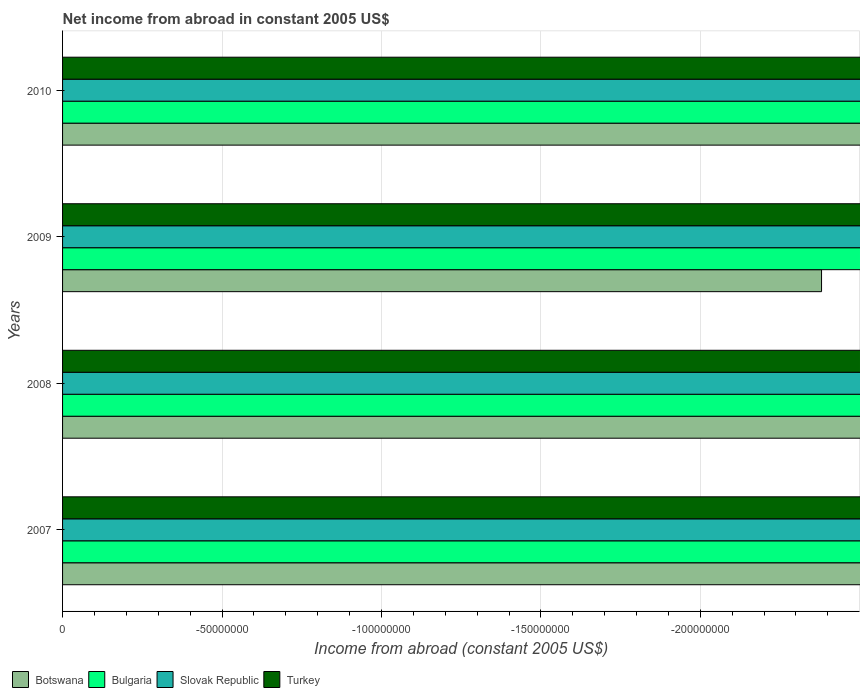Are the number of bars on each tick of the Y-axis equal?
Your answer should be very brief. Yes. How many bars are there on the 3rd tick from the top?
Your answer should be compact. 0. What is the net income from abroad in Botswana in 2007?
Your answer should be compact. 0. Across all years, what is the minimum net income from abroad in Slovak Republic?
Offer a very short reply. 0. What is the total net income from abroad in Botswana in the graph?
Your answer should be compact. 0. Are all the bars in the graph horizontal?
Give a very brief answer. Yes. Where does the legend appear in the graph?
Keep it short and to the point. Bottom left. How are the legend labels stacked?
Your answer should be very brief. Horizontal. What is the title of the graph?
Your response must be concise. Net income from abroad in constant 2005 US$. What is the label or title of the X-axis?
Keep it short and to the point. Income from abroad (constant 2005 US$). What is the label or title of the Y-axis?
Make the answer very short. Years. What is the Income from abroad (constant 2005 US$) of Turkey in 2007?
Keep it short and to the point. 0. What is the Income from abroad (constant 2005 US$) of Slovak Republic in 2008?
Keep it short and to the point. 0. What is the Income from abroad (constant 2005 US$) of Turkey in 2008?
Provide a short and direct response. 0. What is the Income from abroad (constant 2005 US$) in Bulgaria in 2009?
Your answer should be compact. 0. What is the Income from abroad (constant 2005 US$) of Turkey in 2009?
Give a very brief answer. 0. What is the Income from abroad (constant 2005 US$) in Botswana in 2010?
Your answer should be very brief. 0. What is the Income from abroad (constant 2005 US$) in Slovak Republic in 2010?
Offer a very short reply. 0. What is the total Income from abroad (constant 2005 US$) in Botswana in the graph?
Your answer should be compact. 0. What is the total Income from abroad (constant 2005 US$) of Bulgaria in the graph?
Give a very brief answer. 0. What is the total Income from abroad (constant 2005 US$) of Turkey in the graph?
Your response must be concise. 0. What is the average Income from abroad (constant 2005 US$) in Botswana per year?
Keep it short and to the point. 0. What is the average Income from abroad (constant 2005 US$) of Bulgaria per year?
Keep it short and to the point. 0. What is the average Income from abroad (constant 2005 US$) in Slovak Republic per year?
Provide a succinct answer. 0. 